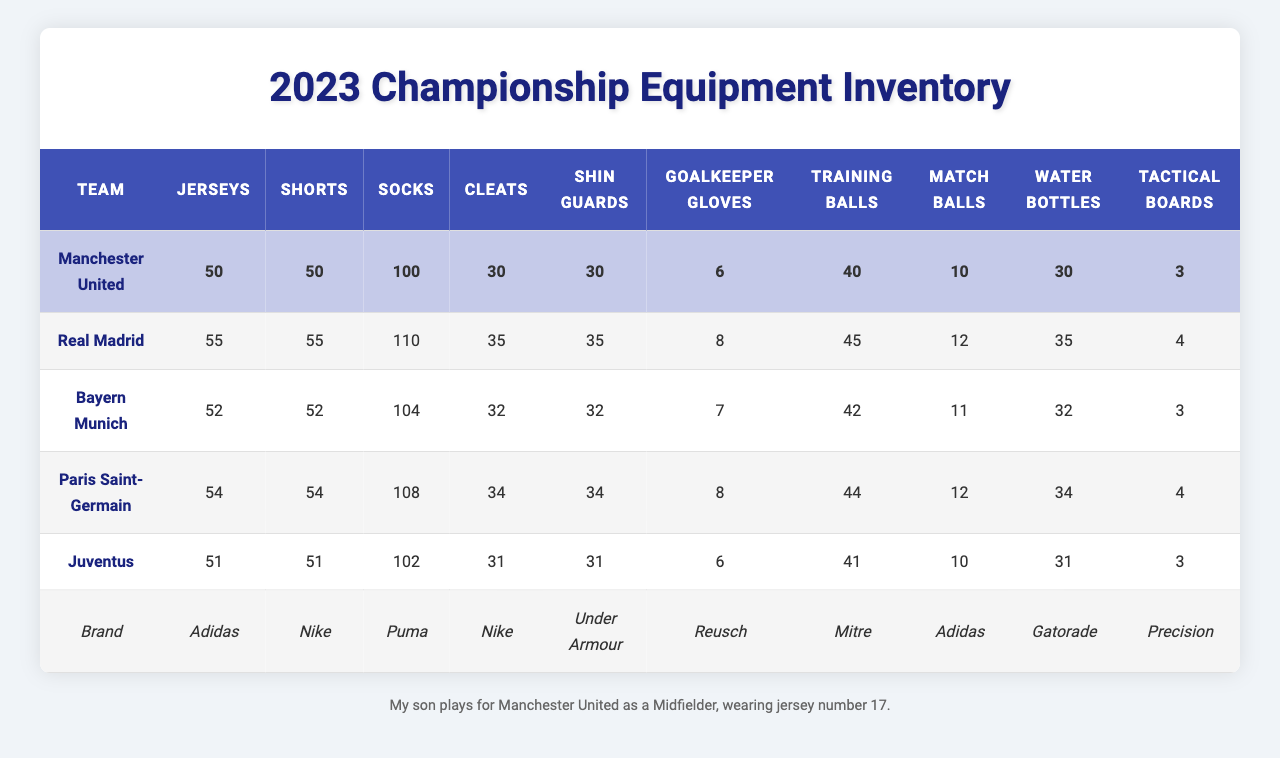What team has the most jerseys? According to the table, Real Madrid has the highest number of jerseys at 55.
Answer: Real Madrid What is the total count of training balls across all teams? The total training balls can be found by adding each team's count: 40 + 45 + 42 + 44 + 41 = 212.
Answer: 212 Does Juventus have more shin guards than Bayern Munich? Juventus has 31 shin guards while Bayern Munich has 32 shin guards, making it false that Juventus has more.
Answer: No Which team has the least goalkeeper gloves? Manchester United, Bayern Munich, and Juventus each have 6 or 7, but Manchester United has the least with 6.
Answer: Manchester United What is the average number of match balls across all teams? Calculating the average involves summing the match balls (10 + 12 + 11 + 12 + 10 = 55) and dividing by the number of teams (55 / 5 = 11).
Answer: 11 Are there more water bottles in Real Madrid than in Paris Saint-Germain? Real Madrid has 35 water bottles while Paris Saint-Germain has 34, so the statement is true.
Answer: Yes Which team uses the most socks? Real Madrid leads with 110 socks, which is the highest count among all teams listed.
Answer: Real Madrid What is the difference in the number of cleats between the team with the most and the least? Real Madrid has 35 cleats, and Manchester United has 30, making the difference 35 - 30 = 5.
Answer: 5 Does Manchester United use Adidas for their jerseys? Yes, according to the equipment brands table, Adidas is the brand for all jerseys, including those for Manchester United.
Answer: Yes If we combine the total cleats for Bayern Munich and Manchester United, what do we get? Bayern Munich has 32 cleats and Manchester United has 30; adding them gives 32 + 30 = 62 cleats combined.
Answer: 62 